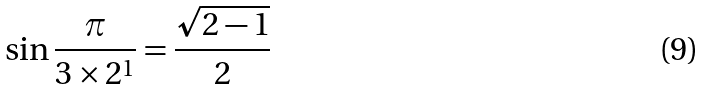Convert formula to latex. <formula><loc_0><loc_0><loc_500><loc_500>\sin { \frac { \pi } { 3 \times 2 ^ { 1 } } } = { \frac { \sqrt { 2 - 1 } } { 2 } }</formula> 